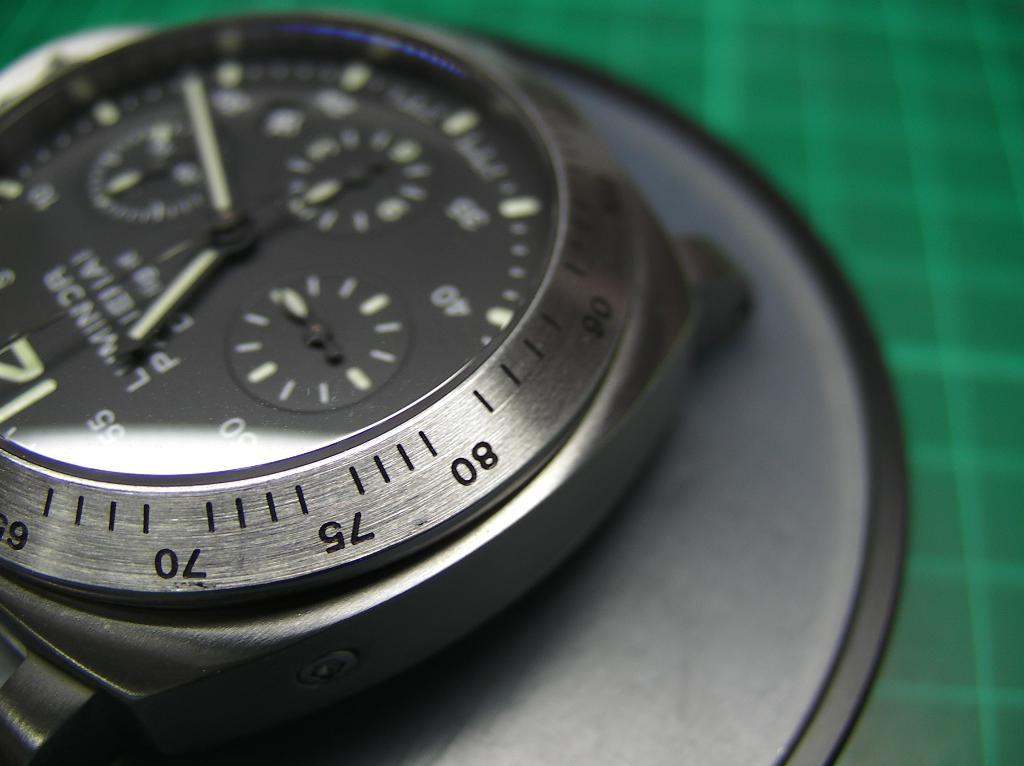<image>
Share a concise interpretation of the image provided. A watch face that says McNinnon and shows it to be about twenty after eleven. 